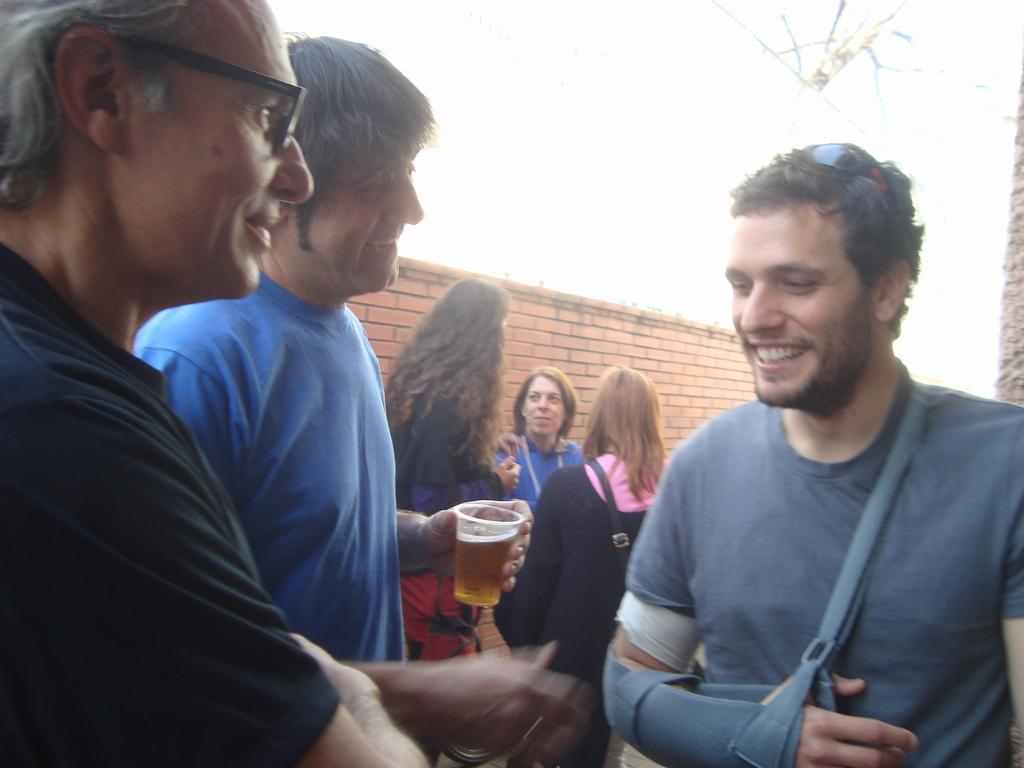Describe this image in one or two sentences. This is picture taken outside a house. In this picture in the foreground there are three people standing, all are smiling. In the center a person is holding a drink. In the background there are three women standing. On the top there is a brick wall. 